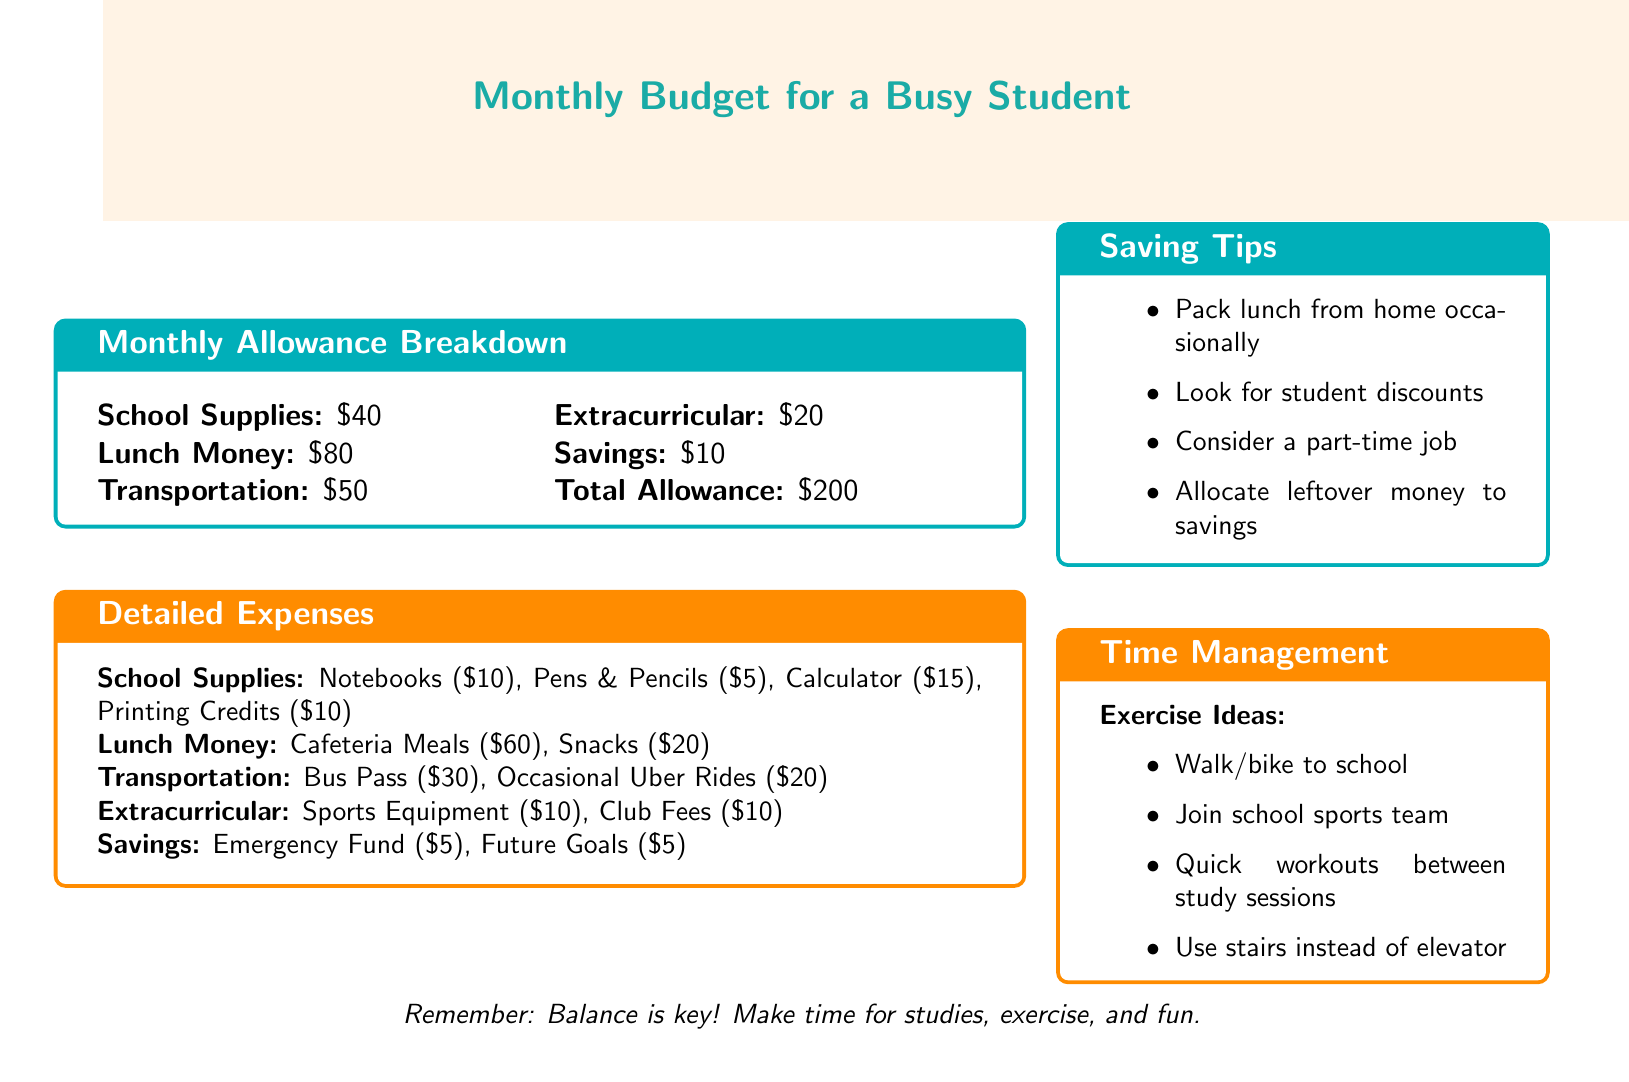What is the total allowance? The total allowance is clearly stated in the document as the sum of all categories.
Answer: $200 How much is allocated for school supplies? The document specifies the amount allocated for school supplies directly.
Answer: $40 What are the expenses for lunch money? The document lists the breakdown of lunch money expenses in detail.
Answer: $80 What is included in transportation expenses? Transportation expenses are broken down into categories in the document, providing clarity on what is included.
Answer: Bus Pass and Occasional Uber Rides How much is allocated for savings? The document states the savings amount separately, which is easy to find.
Answer: $10 What are some saving tips mentioned? The document provides a list of saving tips that could be followed to reduce expenses.
Answer: Pack lunch from home occasionally How much is spent on extracurricular activities? The document specifies the total amount spent on extracurricular activities as a single category.
Answer: $20 What idea is suggested for incorporating exercise? The document provides suggestions regarding exercise that can fit into a student’s busy schedule.
Answer: Walk/bike to school What is the breakdown of lunch money expenses? The document lists the specific expenses under lunch money, making it possible to see what the total includes.
Answer: Cafeteria Meals and Snacks 